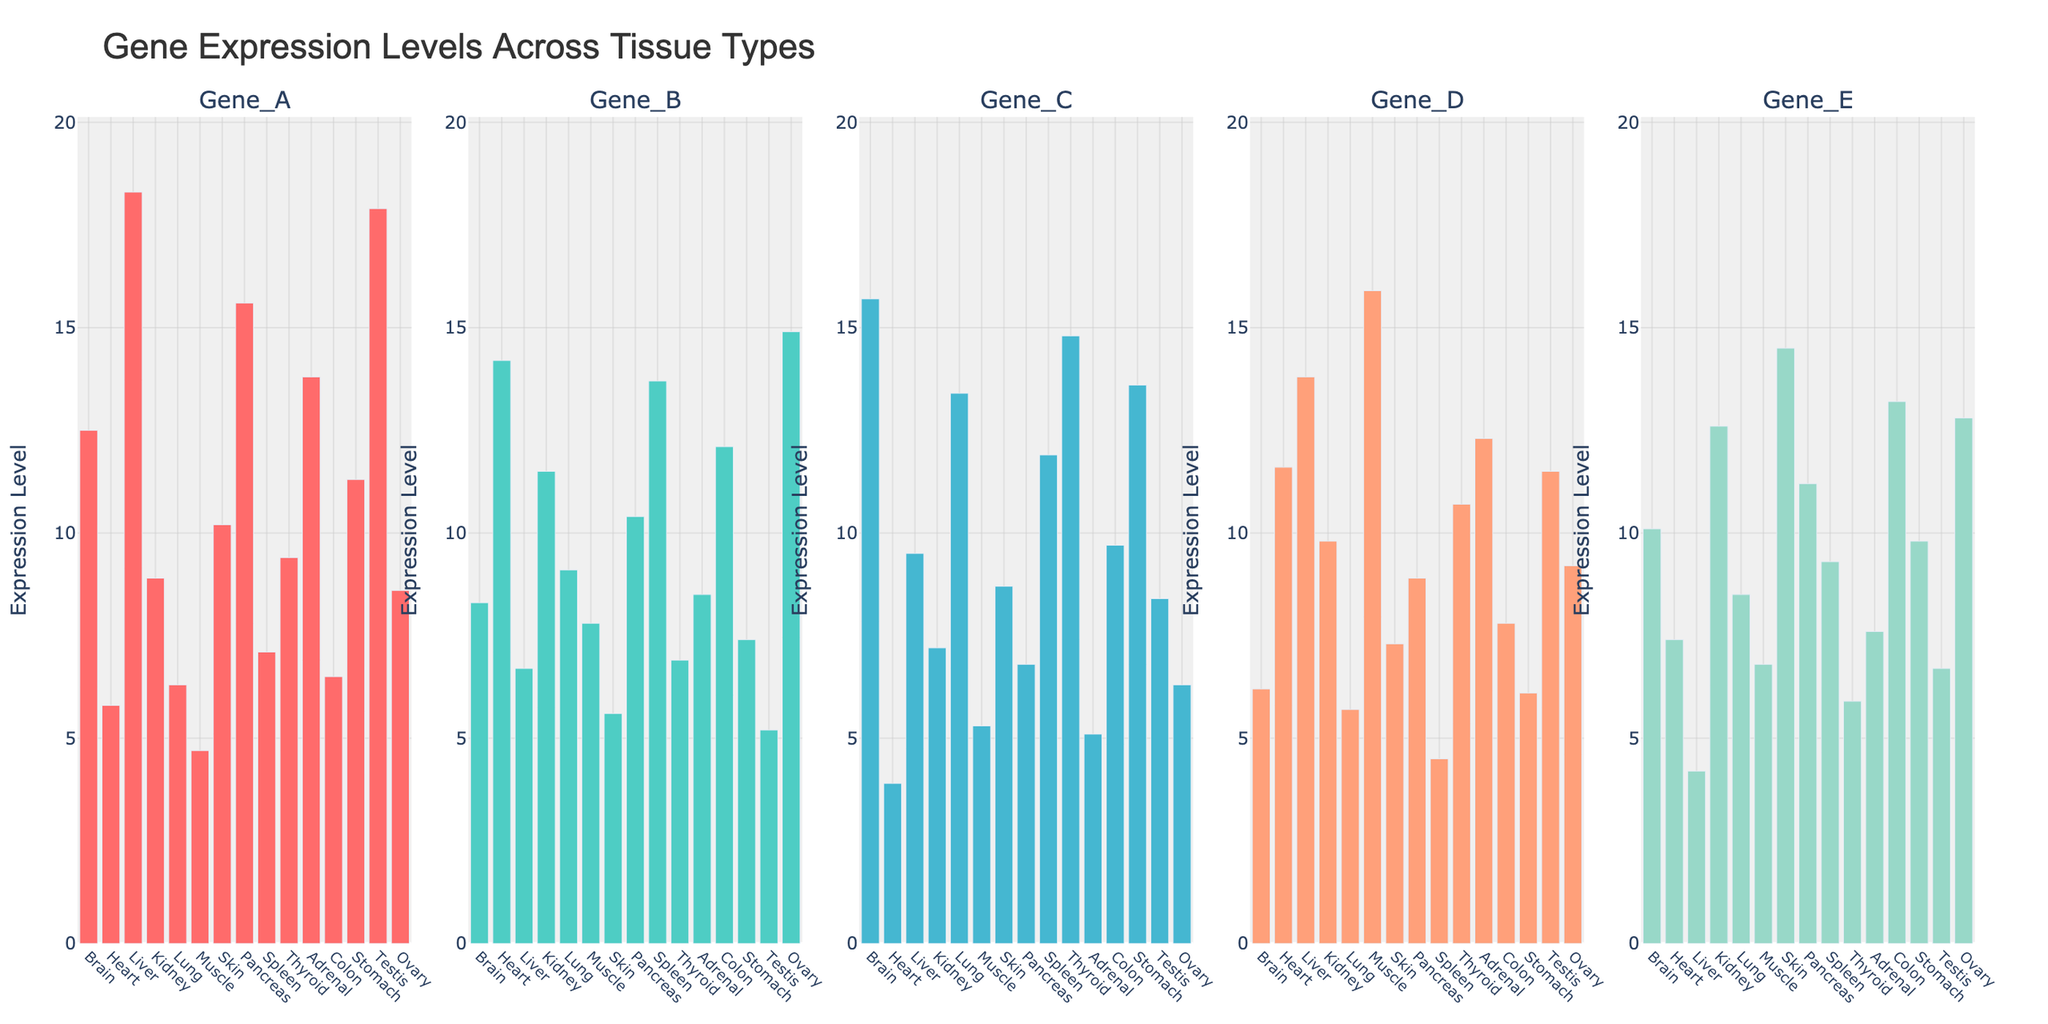What is the highest expression level of Gene_A and in which tissue is it found? First, identify the tallest bar in the first subplot (Gene_A). The highest bar corresponds to the Liver with an expression level of 18.3.
Answer: 18.3 in Liver Which tissue has the lowest expression level for Gene_D? Examine the fourth subplot (Gene_D) and identify the shortest bar, which corresponds to the Spleen with an expression level of 4.5.
Answer: Spleen What is the total expression level of Gene_B across all tissues? Sum the heights of all bars in the second subplot (Gene_B): 8.3 + 14.2 + 6.7 + 11.5 + 9.1 + 7.8 + 5.6 + 10.4 + 13.7 + 6.9 + 8.5 + 12.1 + 7.4 + 5.2 + 14.9 = 142.3.
Answer: 142.3 Compare the expression levels of Gene_C in the Brain and Liver tissues; which one is higher and by how much? Refer to the third subplot (Gene_C) and find the Brain and Liver bars. Brain: 15.7, Liver: 9.5. The difference is 15.7 - 9.5 = 6.2, indicating Brain has a higher expression level by 6.2.
Answer: Brain is higher by 6.2 In which tissues is the expression level of Gene_E greater than 12? Look at the fifth subplot (Gene_E) and identify bars taller than the 12 mark: Kidney (12.6), Skin (14.5), Colon (13.2), and Ovary (12.8).
Answer: Kidney, Skin, Colon, Ovary Among all genes, which gene shows the highest expression in the Heart tissue? Examine all subplots for the Heart tissue. The highest bar for Heart is Gene_B with a level of 14.2.
Answer: Gene_B Calculate the mean expression level of Gene_D across all tissues. For Gene_D (fourth subplot): sum = 6.2 + 11.6 + 13.8 + 9.8 + 5.7 + 15.9 + 7.3 + 8.9 + 4.5 + 10.7 + 12.3 + 7.8 + 6.1 + 11.5 + 9.2 = 141.3. Mean = 141.3 / 15 = 9.42.
Answer: 9.42 Which gene has the most uniform expression levels across all tissues, judging by the height variance of the bars? Visually compare the variability in bar heights across all subplots. Gene_B (second subplot) shows relatively uniform heights with less drastic differences.
Answer: Gene_B 